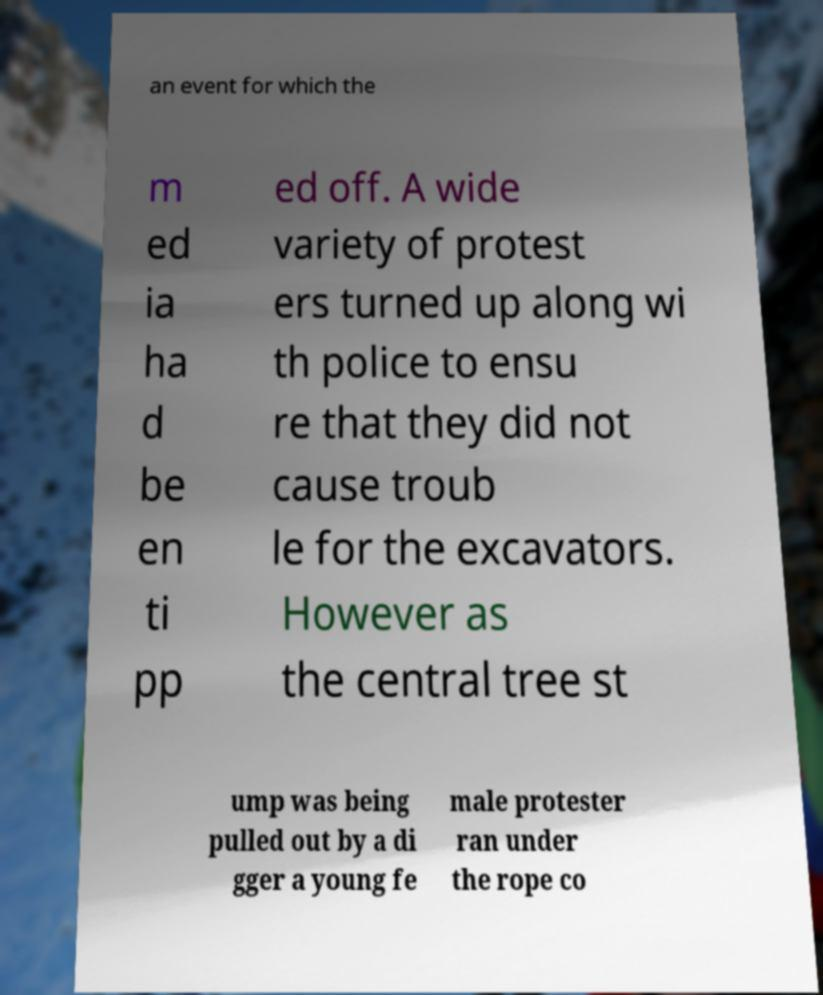Could you assist in decoding the text presented in this image and type it out clearly? an event for which the m ed ia ha d be en ti pp ed off. A wide variety of protest ers turned up along wi th police to ensu re that they did not cause troub le for the excavators. However as the central tree st ump was being pulled out by a di gger a young fe male protester ran under the rope co 